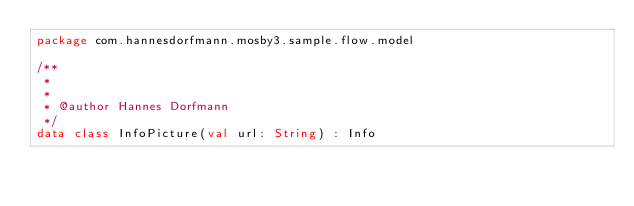Convert code to text. <code><loc_0><loc_0><loc_500><loc_500><_Kotlin_>package com.hannesdorfmann.mosby3.sample.flow.model

/**
 *
 *
 * @author Hannes Dorfmann
 */
data class InfoPicture(val url: String) : Info</code> 